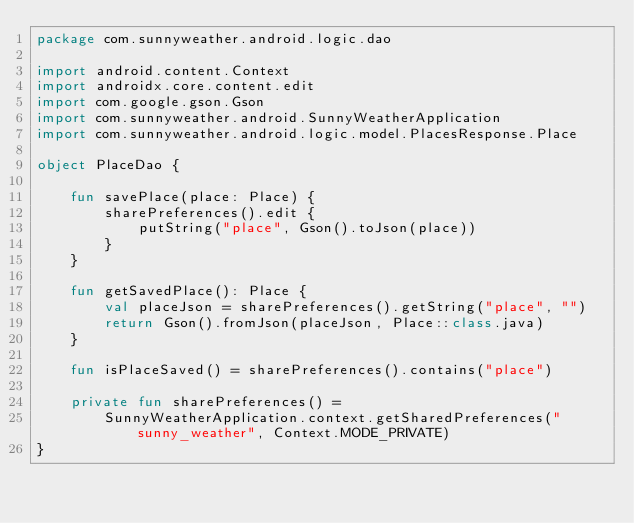<code> <loc_0><loc_0><loc_500><loc_500><_Kotlin_>package com.sunnyweather.android.logic.dao

import android.content.Context
import androidx.core.content.edit
import com.google.gson.Gson
import com.sunnyweather.android.SunnyWeatherApplication
import com.sunnyweather.android.logic.model.PlacesResponse.Place

object PlaceDao {

    fun savePlace(place: Place) {
        sharePreferences().edit {
            putString("place", Gson().toJson(place))
        }
    }

    fun getSavedPlace(): Place {
        val placeJson = sharePreferences().getString("place", "")
        return Gson().fromJson(placeJson, Place::class.java)
    }

    fun isPlaceSaved() = sharePreferences().contains("place")

    private fun sharePreferences() =
        SunnyWeatherApplication.context.getSharedPreferences("sunny_weather", Context.MODE_PRIVATE)
}</code> 